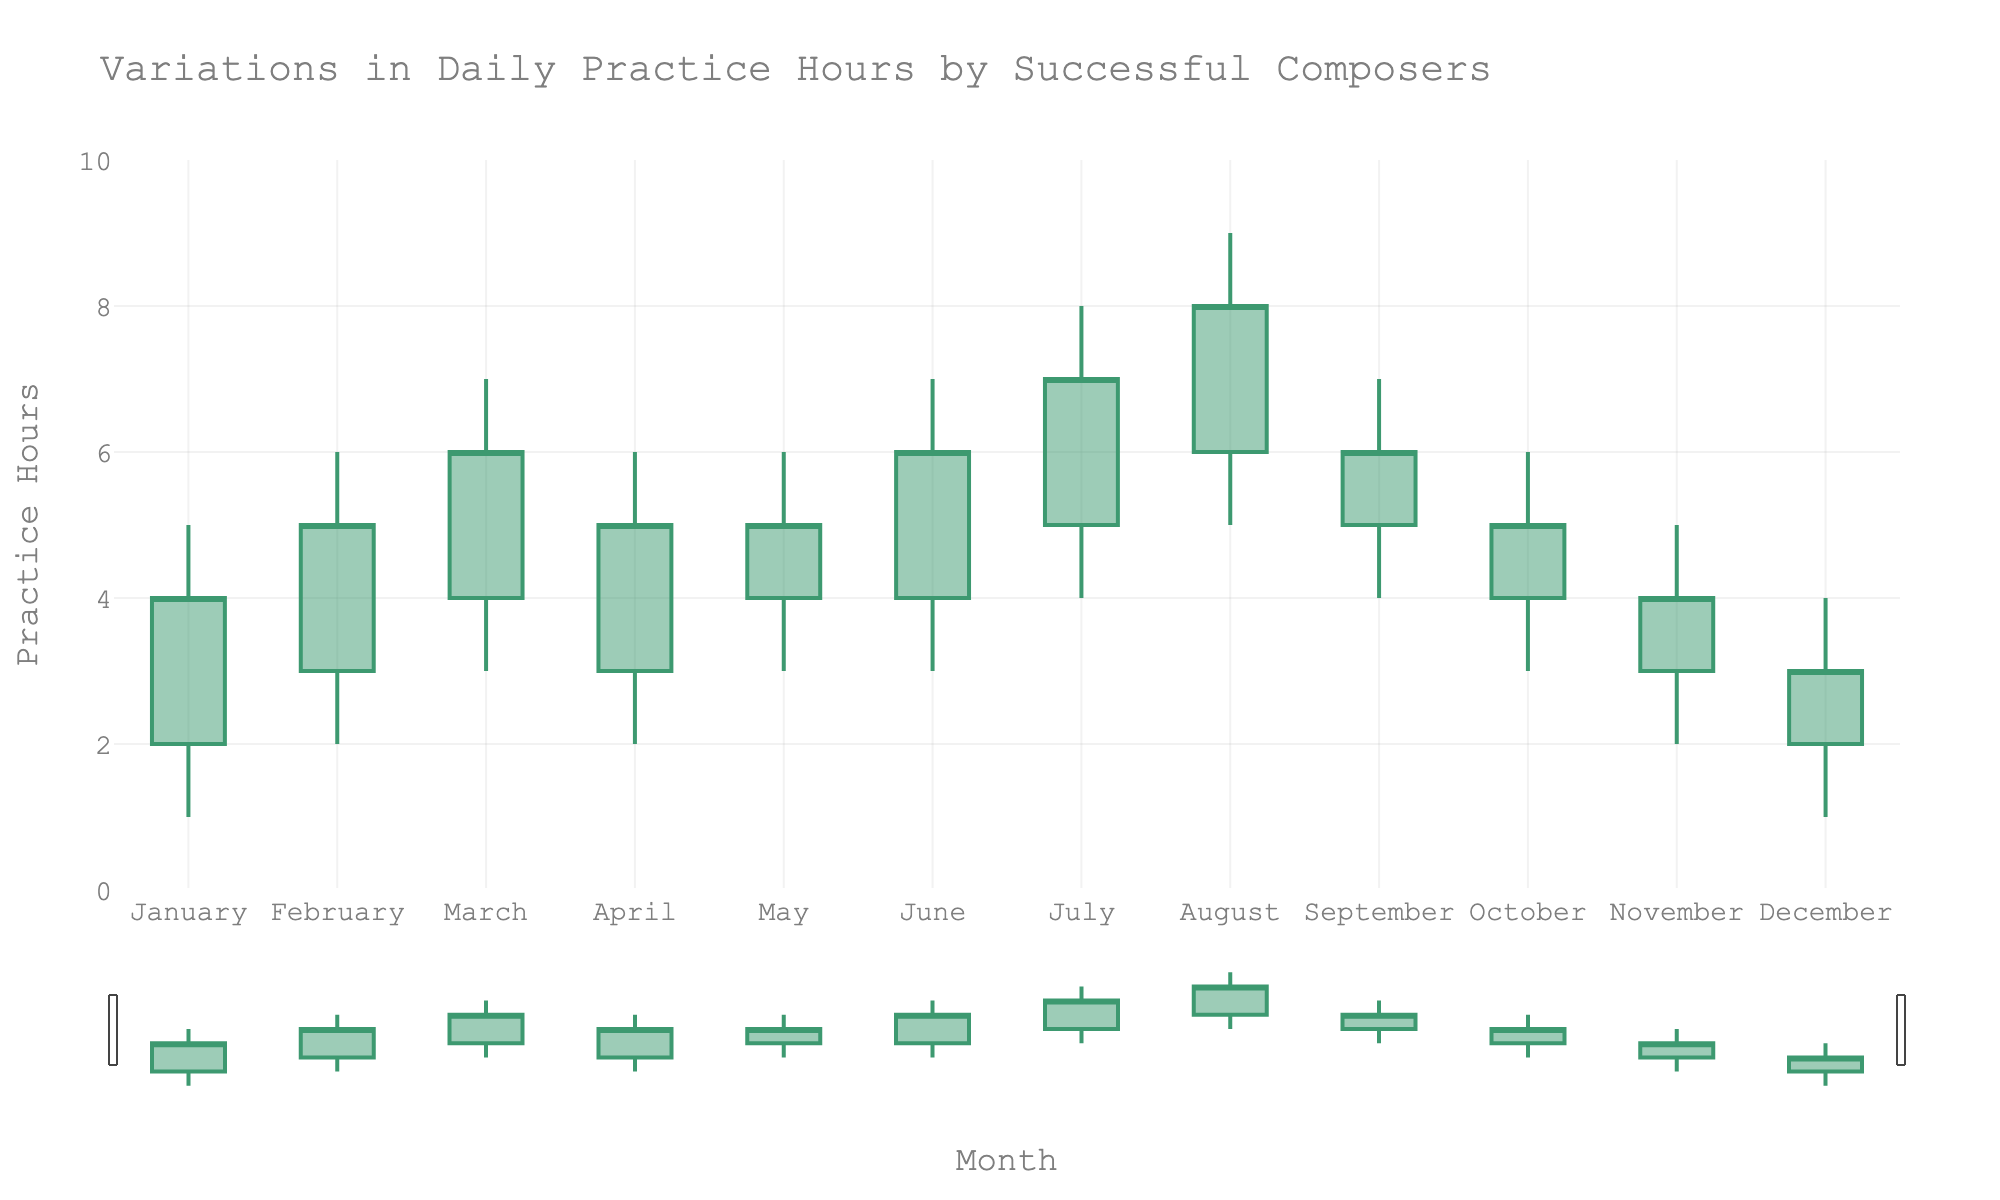What's the title of the plot? The title of the plot is located at the top of the figure, centered. It is written in the largest font.
Answer: Variations in Daily Practice Hours by Successful Composers What does the y-axis represent? The y-axis title is positioned vertically along the left side of the plot, specifying the variable measured.
Answer: Practice Hours In which month is the highest practice hour recorded? The highest practice hour recorded can be determined by looking at the highest value reached by the candlestick bars on the y-axis.
Answer: August During which month did the practice hours close at 4? "Closing" in a candlestick plot is indicated by the top or bottom of the rectangle (depending on whether it increased or decreased). By locating a closing value of 4 on the y-axis and cross-referencing it with the month on the x-axis, the correct month can be found.
Answer: January How many months have the same high value of 6 practice hours? Count the number of candlesticks that have their highest point reaching the value of 6 on the y-axis.
Answer: 5 What is the average closing practice hours for the second quarter (April, May, June)? Locate the closing values for April, May, and June, sum these values, and then divide by 3 for the average. Closing values are 5, 5, and 6. (5+5+6) / 3 = 16 / 3
Answer: 5.33 Which month has the smallest range of practice hours? The range is calculated as the difference between the high and low values in each candlestick. Compare the ranges for each month and identify the smallest.
Answer: May Compare the range of practice hours between July and December. Which is greater? The range is found by subtracting the low value from the high value for both months. For July, it is 8 - 4 = 4. For December, it is 4 - 1 = 3.
Answer: July Which month shows the most significant decrease in practice hours? A "significant decrease" is represented by a candlestick with a filled rectangle (indicating a decrease) and considerable height difference from open to close values. The month with the largest decrease will have the longest filled rectangle in height.
Answer: December How many months have increasing practice hours? Count the candlesticks where the close value is higher than the open value, signifying an increase (the rectangles unfilled or differently colored for increases).
Answer: 8 